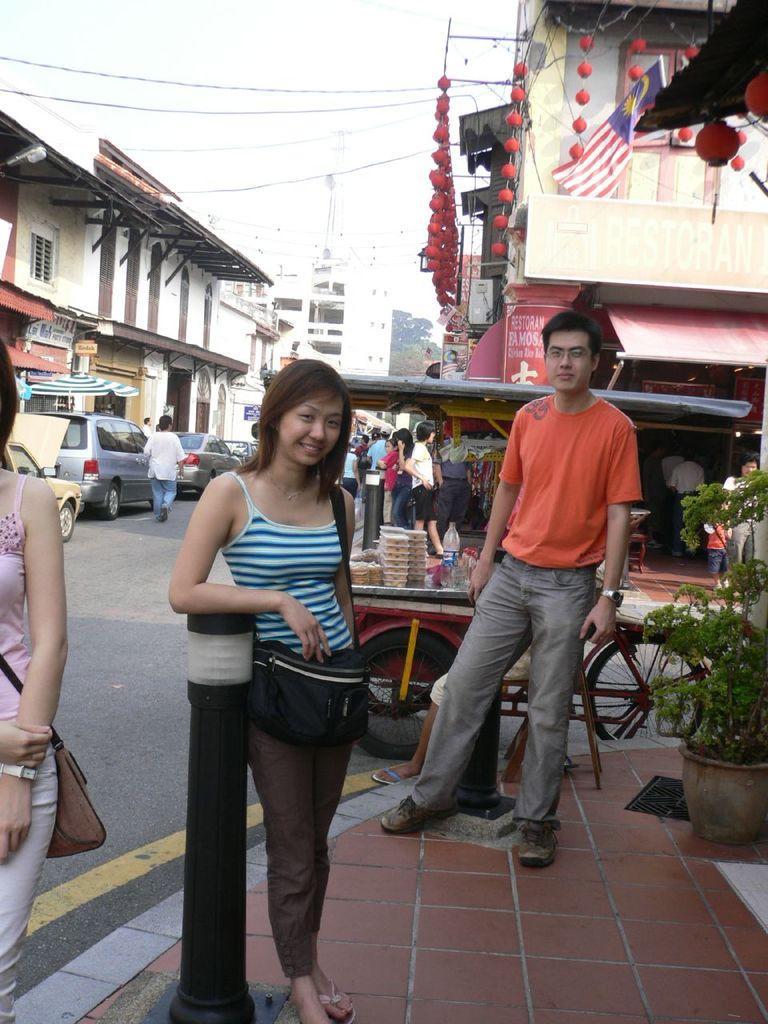How would you summarize this image in a sentence or two? This picture is clicked outside. In the foreground we can see the group of persons standing on the ground. On the left we can see the vehicles and some other objects and we can see a pot and a plant. In the background there is a sky, cables, buildings, trees, flag and group of persons. 